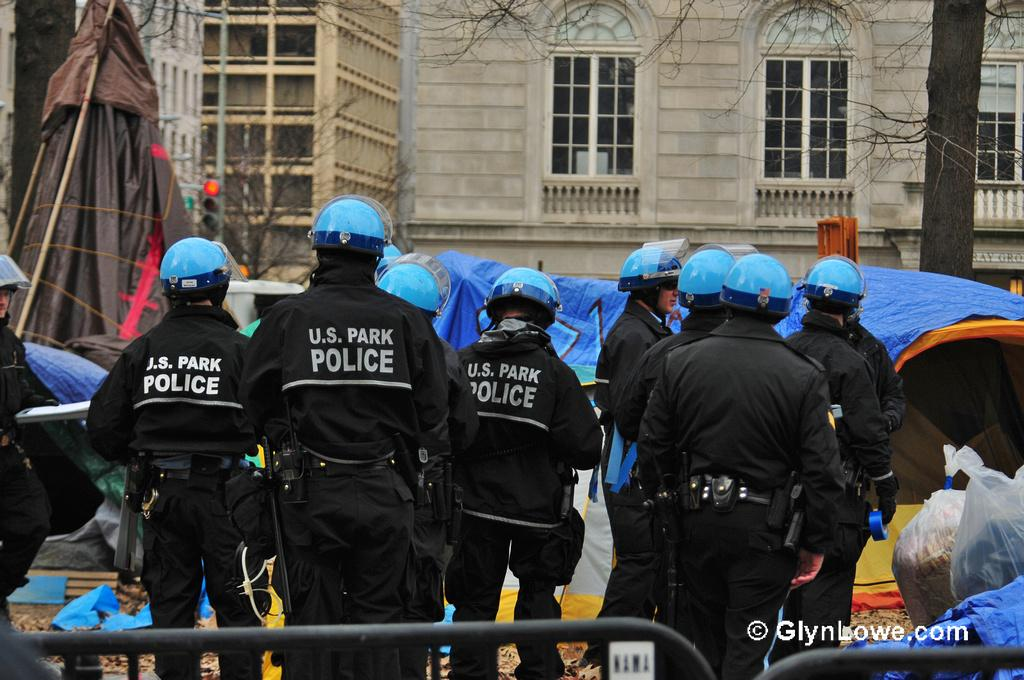What is the setting of the image? The image shows an outside view. What can be seen in the image besides the outdoor setting? There are people wearing clothes in the image. Where are the people standing in relation to the building? The people are standing in front of a building. Can you describe any objects be seen in the top right corner of the image? Yes, there is a trunk in the top right corner of the image. What type of education is being offered in the image? There is no indication of education being offered in the image. What kind of grain is visible in the image? There is no grain present in the image. 